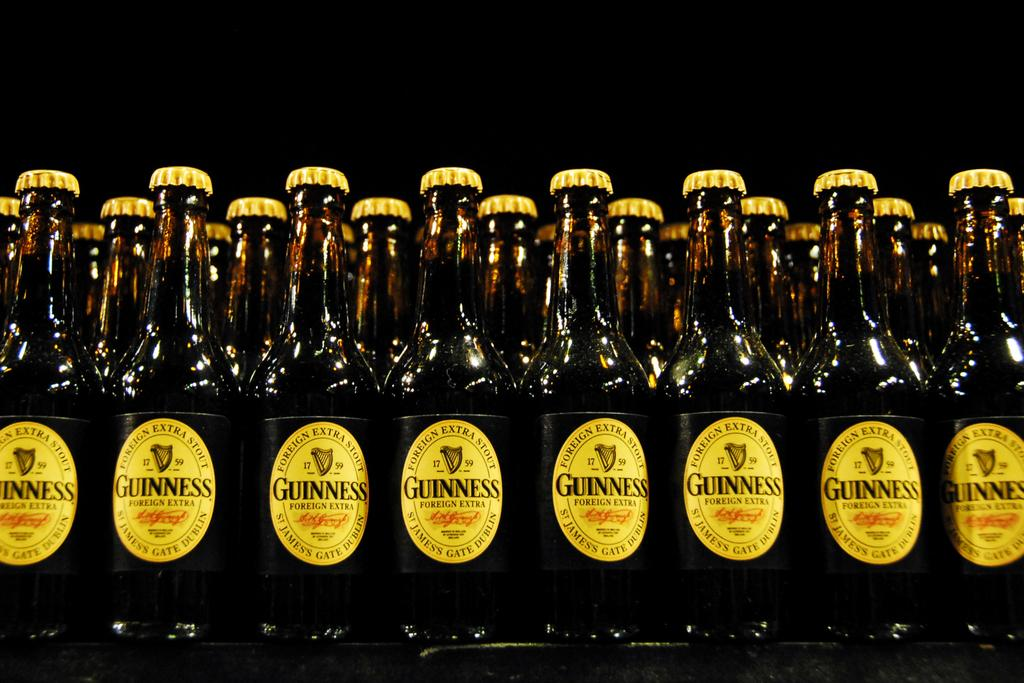<image>
Present a compact description of the photo's key features. Two rows of Guinness bottles are lined up next to each other on a table. 